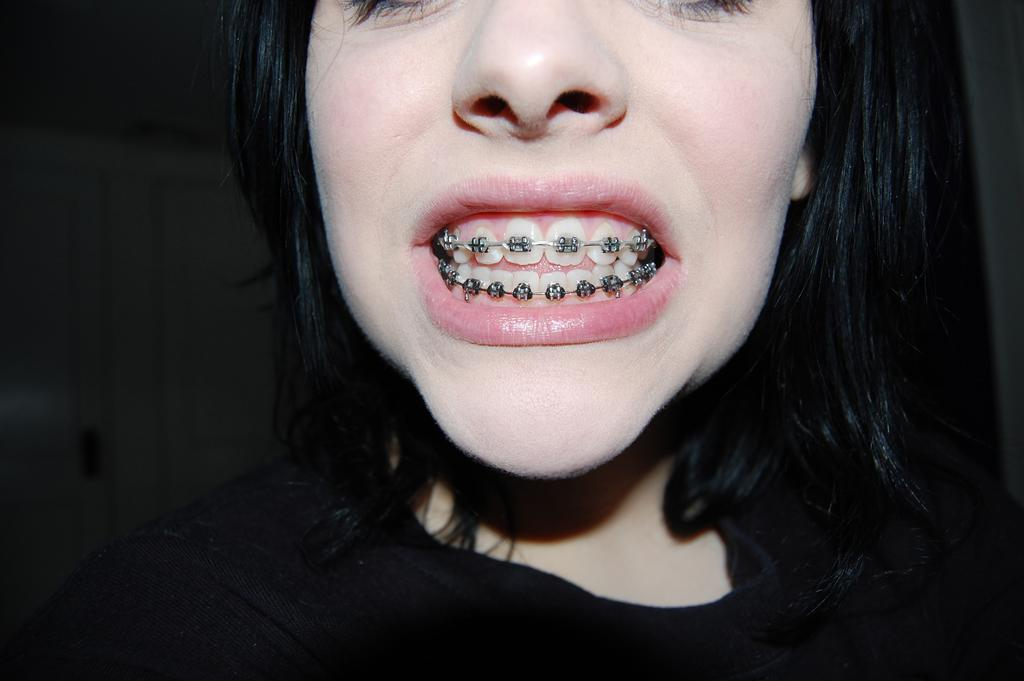Who is the main subject in the image? There is a woman in the image. What is the woman wearing? The woman is wearing a black T-shirt. What is the woman doing with her teeth? The woman is showing her teeth with a clip attached. What can be seen in the background of the image? There is a white door visible in the background of the image. Can you see a spot on the basketball in the image? There is no basketball present in the image. Is there a fly buzzing around the woman's head in the image? There is no fly visible in the image. 